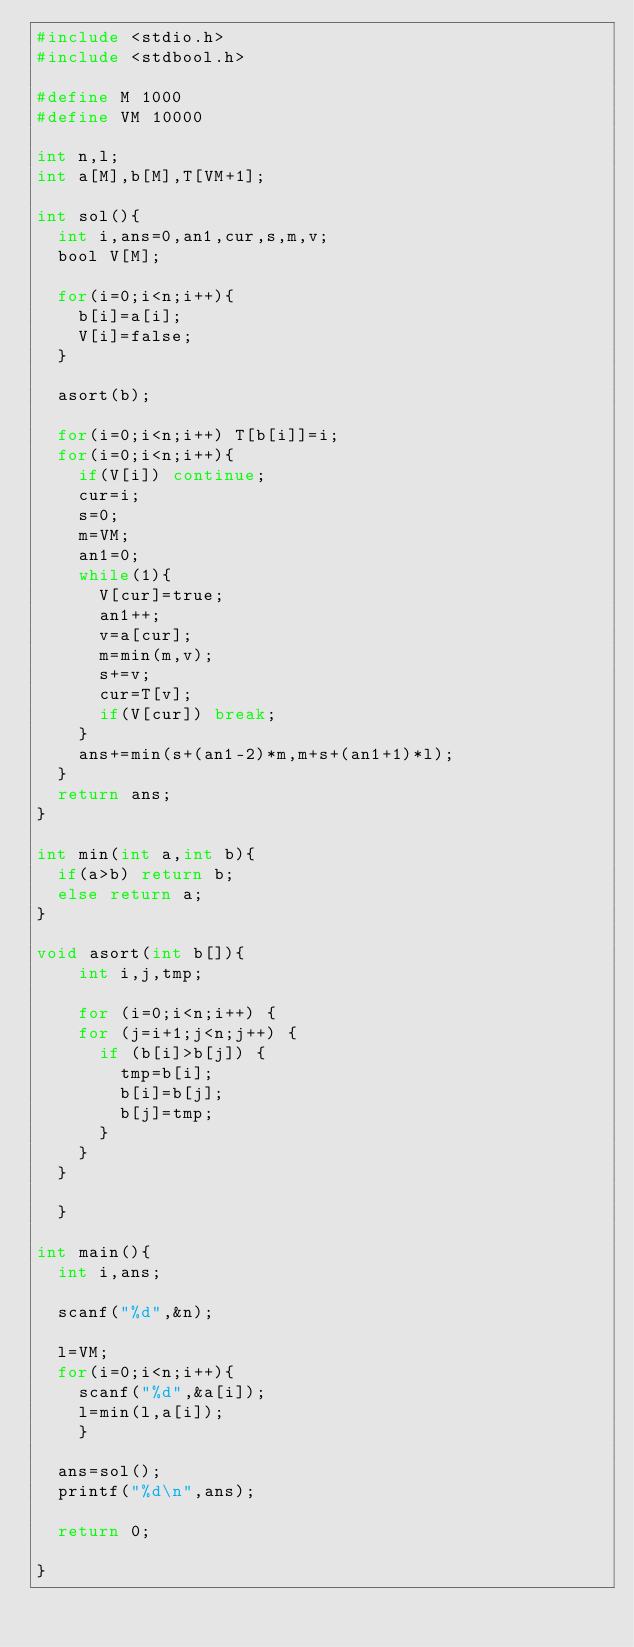Convert code to text. <code><loc_0><loc_0><loc_500><loc_500><_C_>#include <stdio.h>
#include <stdbool.h>

#define M 1000
#define VM 10000

int n,l;
int a[M],b[M],T[VM+1];

int sol(){
  int i,ans=0,an1,cur,s,m,v;
  bool V[M];

  for(i=0;i<n;i++){
    b[i]=a[i];
    V[i]=false;
  }

  asort(b);

  for(i=0;i<n;i++) T[b[i]]=i;
  for(i=0;i<n;i++){
    if(V[i]) continue;
    cur=i;
    s=0;
    m=VM;
    an1=0;
    while(1){
      V[cur]=true;
      an1++;
      v=a[cur];
      m=min(m,v);
      s+=v;
      cur=T[v];
      if(V[cur]) break;
    }
    ans+=min(s+(an1-2)*m,m+s+(an1+1)*l);
  }
  return ans;
}

int min(int a,int b){
  if(a>b) return b;
  else return a;
}
      
void asort(int b[]){
    int i,j,tmp;
    
    for (i=0;i<n;i++) {
    for (j=i+1;j<n;j++) {
      if (b[i]>b[j]) {
        tmp=b[i];
        b[i]=b[j];
        b[j]=tmp;
      }
    }
  }

  }

int main(){
  int i,ans;
  
  scanf("%d",&n);

  l=VM;
  for(i=0;i<n;i++){
    scanf("%d",&a[i]);
    l=min(l,a[i]);
	  }

  ans=sol();
  printf("%d\n",ans);
  
  return 0;
  
}</code> 